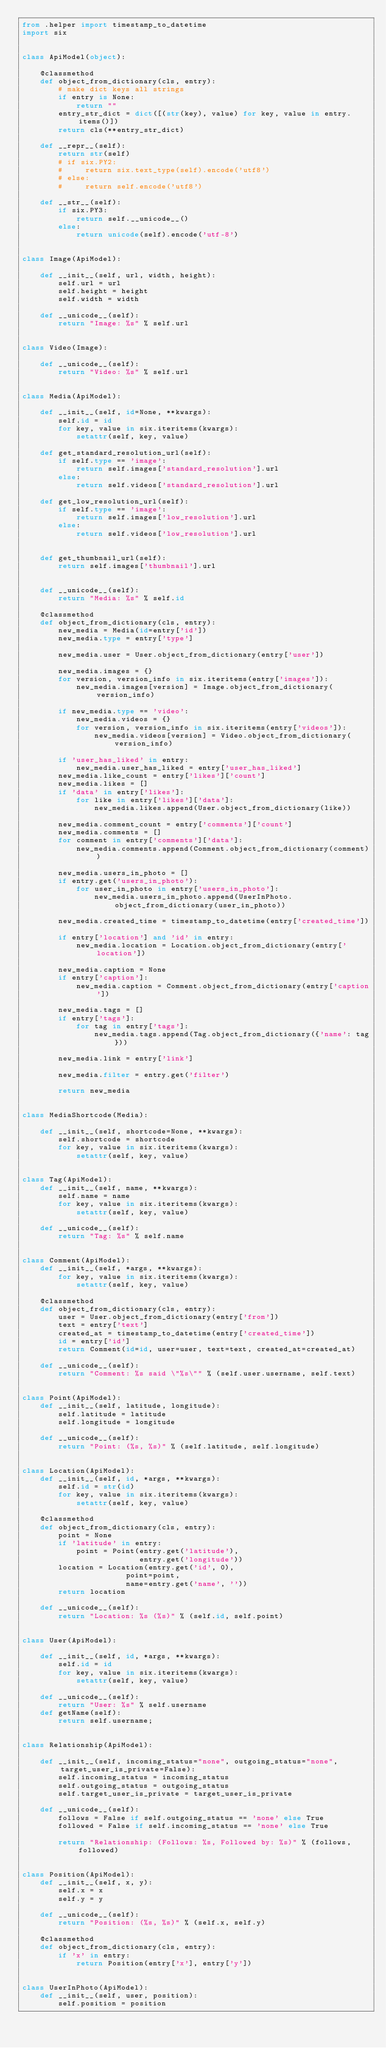Convert code to text. <code><loc_0><loc_0><loc_500><loc_500><_Python_>from .helper import timestamp_to_datetime
import six


class ApiModel(object):

    @classmethod
    def object_from_dictionary(cls, entry):
        # make dict keys all strings
        if entry is None:
            return ""
        entry_str_dict = dict([(str(key), value) for key, value in entry.items()])
        return cls(**entry_str_dict)

    def __repr__(self):
        return str(self)
        # if six.PY2:
        #     return six.text_type(self).encode('utf8')
        # else:
        #     return self.encode('utf8')

    def __str__(self):
        if six.PY3:
            return self.__unicode__()
        else:
            return unicode(self).encode('utf-8')


class Image(ApiModel):

    def __init__(self, url, width, height):
        self.url = url
        self.height = height
        self.width = width

    def __unicode__(self):
        return "Image: %s" % self.url


class Video(Image):

    def __unicode__(self):
        return "Video: %s" % self.url


class Media(ApiModel):

    def __init__(self, id=None, **kwargs):
        self.id = id
        for key, value in six.iteritems(kwargs):
            setattr(self, key, value)

    def get_standard_resolution_url(self):
        if self.type == 'image':
            return self.images['standard_resolution'].url
        else:
            return self.videos['standard_resolution'].url

    def get_low_resolution_url(self):
        if self.type == 'image':
            return self.images['low_resolution'].url
        else:
            return self.videos['low_resolution'].url


    def get_thumbnail_url(self):
        return self.images['thumbnail'].url


    def __unicode__(self):
        return "Media: %s" % self.id

    @classmethod
    def object_from_dictionary(cls, entry):
        new_media = Media(id=entry['id'])
        new_media.type = entry['type']

        new_media.user = User.object_from_dictionary(entry['user'])

        new_media.images = {}
        for version, version_info in six.iteritems(entry['images']):
            new_media.images[version] = Image.object_from_dictionary(version_info)

        if new_media.type == 'video':
            new_media.videos = {}
            for version, version_info in six.iteritems(entry['videos']):
                new_media.videos[version] = Video.object_from_dictionary(version_info)

        if 'user_has_liked' in entry:
            new_media.user_has_liked = entry['user_has_liked']
        new_media.like_count = entry['likes']['count']
        new_media.likes = []
        if 'data' in entry['likes']:
            for like in entry['likes']['data']:
                new_media.likes.append(User.object_from_dictionary(like))

        new_media.comment_count = entry['comments']['count']
        new_media.comments = []
        for comment in entry['comments']['data']:
            new_media.comments.append(Comment.object_from_dictionary(comment))

        new_media.users_in_photo = []
        if entry.get('users_in_photo'):
            for user_in_photo in entry['users_in_photo']:
                new_media.users_in_photo.append(UserInPhoto.object_from_dictionary(user_in_photo))

        new_media.created_time = timestamp_to_datetime(entry['created_time'])

        if entry['location'] and 'id' in entry:
            new_media.location = Location.object_from_dictionary(entry['location'])

        new_media.caption = None
        if entry['caption']:
            new_media.caption = Comment.object_from_dictionary(entry['caption'])

        new_media.tags = []
        if entry['tags']:
            for tag in entry['tags']:
                new_media.tags.append(Tag.object_from_dictionary({'name': tag}))

        new_media.link = entry['link']

        new_media.filter = entry.get('filter')

        return new_media


class MediaShortcode(Media):

    def __init__(self, shortcode=None, **kwargs):
        self.shortcode = shortcode
        for key, value in six.iteritems(kwargs):
            setattr(self, key, value)


class Tag(ApiModel):
    def __init__(self, name, **kwargs):
        self.name = name
        for key, value in six.iteritems(kwargs):
            setattr(self, key, value)

    def __unicode__(self):
        return "Tag: %s" % self.name


class Comment(ApiModel):
    def __init__(self, *args, **kwargs):
        for key, value in six.iteritems(kwargs):
            setattr(self, key, value)

    @classmethod
    def object_from_dictionary(cls, entry):
        user = User.object_from_dictionary(entry['from'])
        text = entry['text']
        created_at = timestamp_to_datetime(entry['created_time'])
        id = entry['id']
        return Comment(id=id, user=user, text=text, created_at=created_at)

    def __unicode__(self):
        return "Comment: %s said \"%s\"" % (self.user.username, self.text)


class Point(ApiModel):
    def __init__(self, latitude, longitude):
        self.latitude = latitude
        self.longitude = longitude

    def __unicode__(self):
        return "Point: (%s, %s)" % (self.latitude, self.longitude)


class Location(ApiModel):
    def __init__(self, id, *args, **kwargs):
        self.id = str(id)
        for key, value in six.iteritems(kwargs):
            setattr(self, key, value)

    @classmethod
    def object_from_dictionary(cls, entry):
        point = None
        if 'latitude' in entry:
            point = Point(entry.get('latitude'),
                          entry.get('longitude'))
        location = Location(entry.get('id', 0),
                       point=point,
                       name=entry.get('name', ''))
        return location

    def __unicode__(self):
        return "Location: %s (%s)" % (self.id, self.point)


class User(ApiModel):

    def __init__(self, id, *args, **kwargs):
        self.id = id
        for key, value in six.iteritems(kwargs):
            setattr(self, key, value)

    def __unicode__(self):
        return "User: %s" % self.username
    def getName(self):
        return self.username;


class Relationship(ApiModel):

    def __init__(self, incoming_status="none", outgoing_status="none", target_user_is_private=False):
        self.incoming_status = incoming_status
        self.outgoing_status = outgoing_status
        self.target_user_is_private = target_user_is_private

    def __unicode__(self):
        follows = False if self.outgoing_status == 'none' else True
        followed = False if self.incoming_status == 'none' else True

        return "Relationship: (Follows: %s, Followed by: %s)" % (follows, followed)


class Position(ApiModel):
    def __init__(self, x, y):
        self.x = x
        self.y = y

    def __unicode__(self):
        return "Position: (%s, %s)" % (self.x, self.y)

    @classmethod
    def object_from_dictionary(cls, entry):
        if 'x' in entry:
            return Position(entry['x'], entry['y'])


class UserInPhoto(ApiModel):
    def __init__(self, user, position):
        self.position = position</code> 